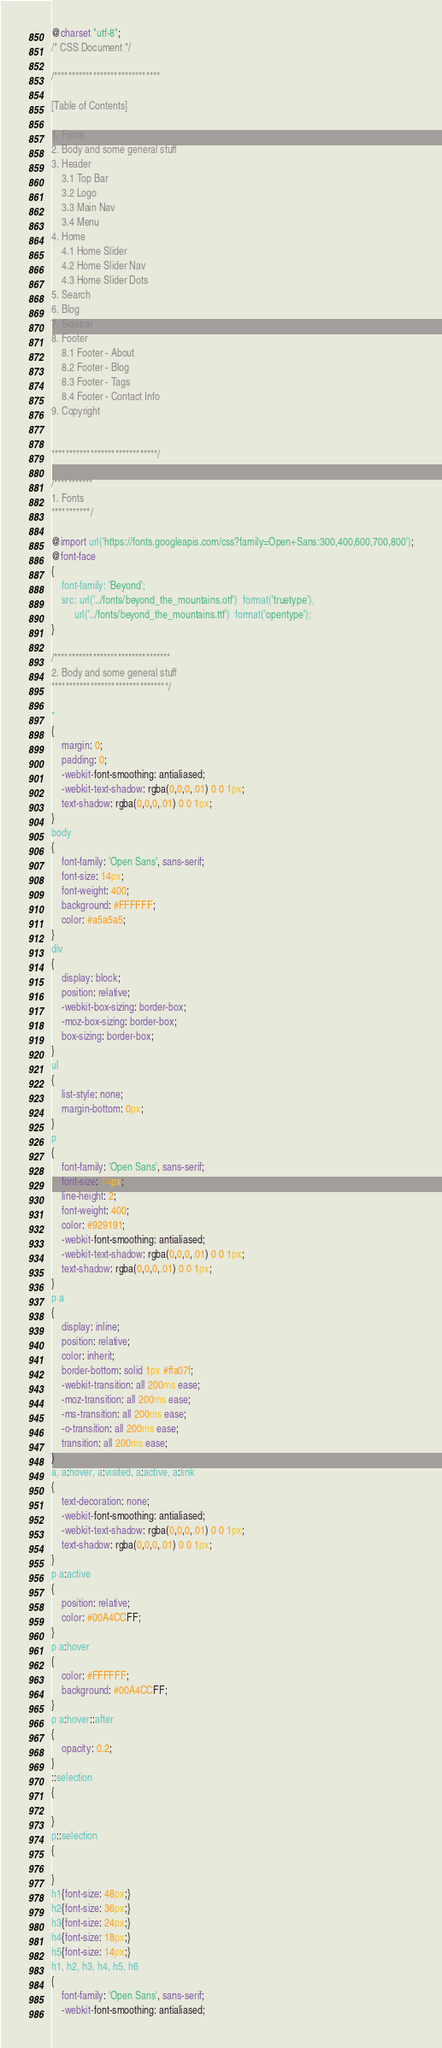Convert code to text. <code><loc_0><loc_0><loc_500><loc_500><_CSS_>@charset "utf-8";
/* CSS Document */

/******************************

[Table of Contents]

1. Fonts
2. Body and some general stuff
3. Header
	3.1 Top Bar
	3.2 Logo
	3.3 Main Nav
	3.4 Menu
4. Home
	4.1 Home Slider
	4.2 Home Slider Nav
	4.3 Home Slider Dots
5. Search
6. Blog
7. Sidebar
8. Footer
	8.1 Footer - About
	8.2 Footer - Blog
	8.3 Footer - Tags
	8.4 Footer - Contact Info
9. Copyright


******************************/

/***********
1. Fonts
***********/

@import url('https://fonts.googleapis.com/css?family=Open+Sans:300,400,600,700,800');
@font-face
{
	font-family: 'Beyond';
	src: url('../fonts/beyond_the_mountains.otf')  format('truetype'),
		 url('../fonts/beyond_the_mountains.ttf')  format('opentype');
}

/*********************************
2. Body and some general stuff
*********************************/

*
{
	margin: 0;
	padding: 0;
	-webkit-font-smoothing: antialiased;
	-webkit-text-shadow: rgba(0,0,0,.01) 0 0 1px;
	text-shadow: rgba(0,0,0,.01) 0 0 1px;
}
body
{
	font-family: 'Open Sans', sans-serif;
	font-size: 14px;
	font-weight: 400;
	background: #FFFFFF;
	color: #a5a5a5;
}
div
{
	display: block;
	position: relative;
	-webkit-box-sizing: border-box;
    -moz-box-sizing: border-box;
    box-sizing: border-box;
}
ul
{
	list-style: none;
	margin-bottom: 0px;
}
p
{
	font-family: 'Open Sans', sans-serif;
	font-size: 14px;
	line-height: 2;
	font-weight: 400;
	color: #929191;
	-webkit-font-smoothing: antialiased;
	-webkit-text-shadow: rgba(0,0,0,.01) 0 0 1px;
	text-shadow: rgba(0,0,0,.01) 0 0 1px;
}
p a
{
	display: inline;
	position: relative;
	color: inherit;
	border-bottom: solid 1px #ffa07f;
	-webkit-transition: all 200ms ease;
	-moz-transition: all 200ms ease;
	-ms-transition: all 200ms ease;
	-o-transition: all 200ms ease;
	transition: all 200ms ease;
}
a, a:hover, a:visited, a:active, a:link
{
	text-decoration: none;
	-webkit-font-smoothing: antialiased;
	-webkit-text-shadow: rgba(0,0,0,.01) 0 0 1px;
	text-shadow: rgba(0,0,0,.01) 0 0 1px;
}
p a:active
{
	position: relative;
	color: #00A4CCFF;
}
p a:hover
{
	color: #FFFFFF;
	background: #00A4CCFF;
}
p a:hover::after
{
	opacity: 0.2;
}
::selection
{
	
}
p::selection
{
	
}
h1{font-size: 48px;}
h2{font-size: 36px;}
h3{font-size: 24px;}
h4{font-size: 18px;}
h5{font-size: 14px;}
h1, h2, h3, h4, h5, h6
{
	font-family: 'Open Sans', sans-serif;
	-webkit-font-smoothing: antialiased;</code> 